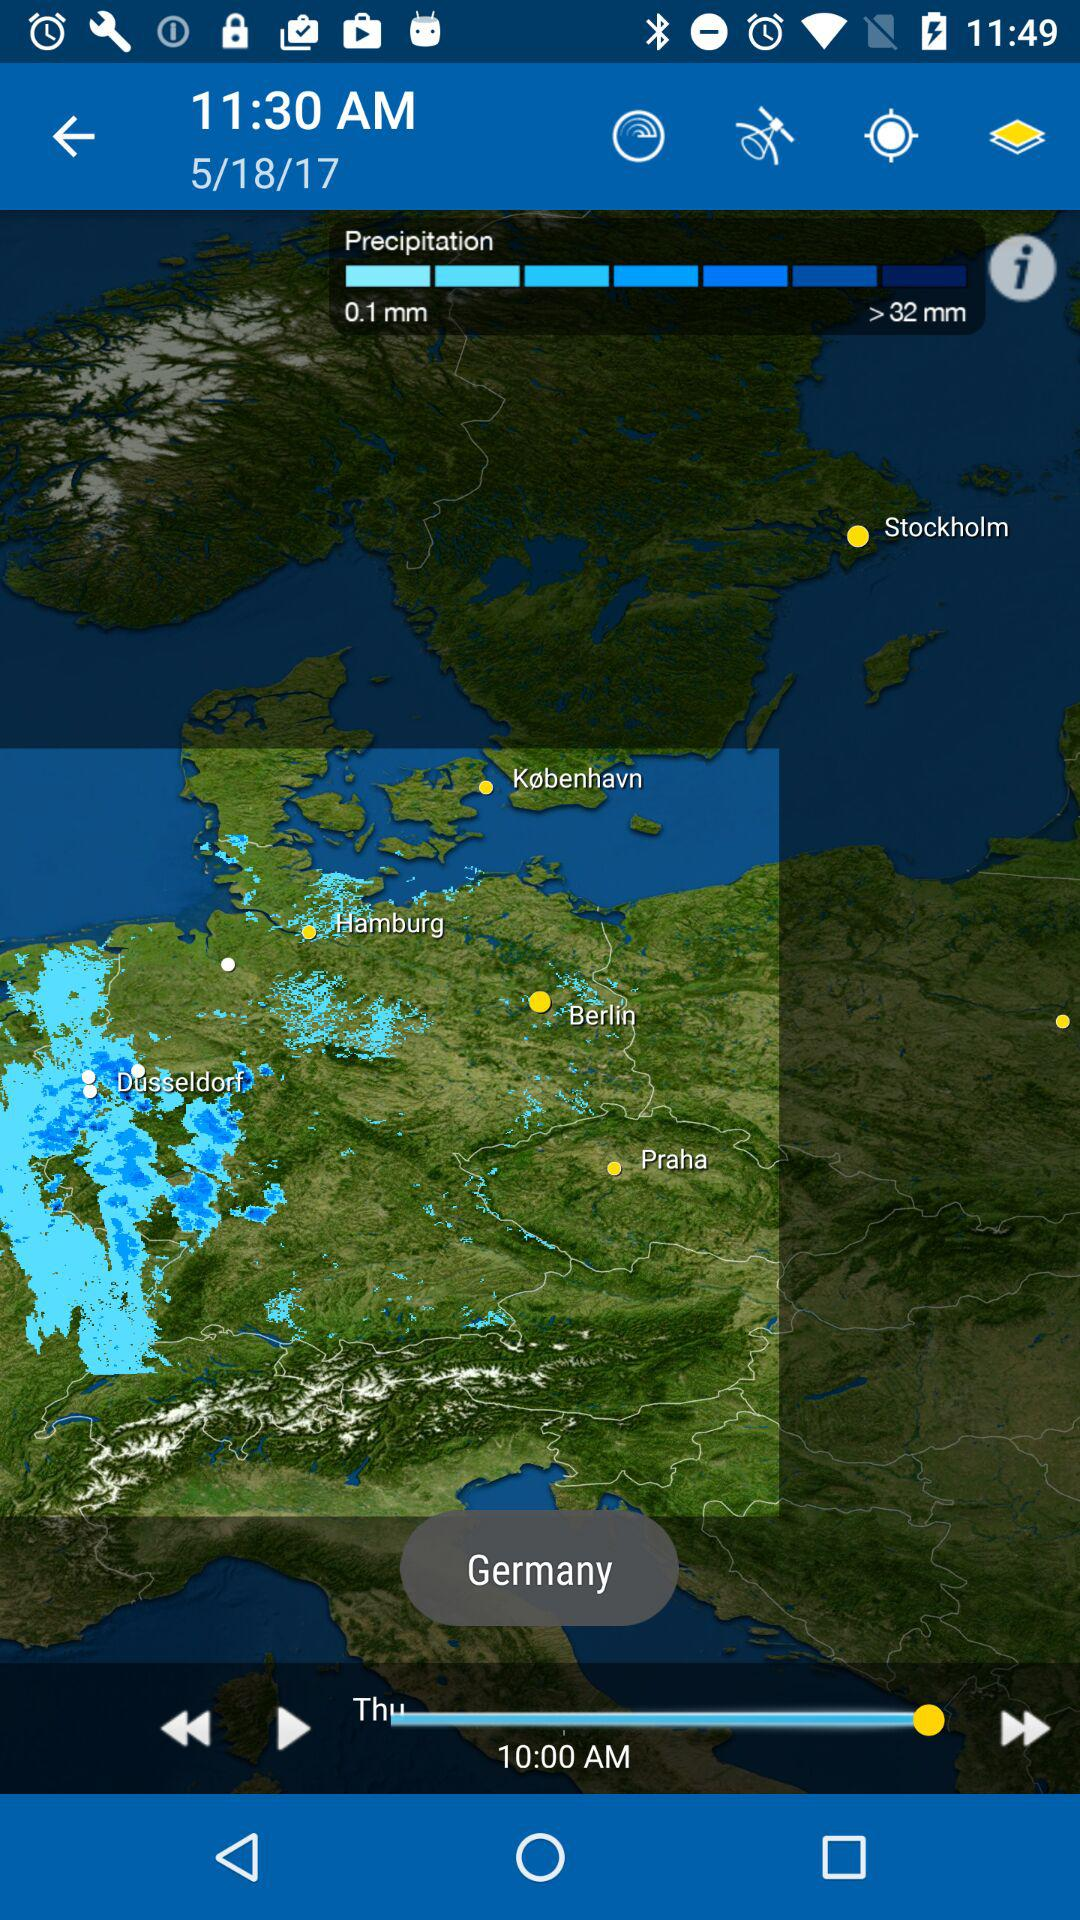What is the date? The date is May 18, 2017. 